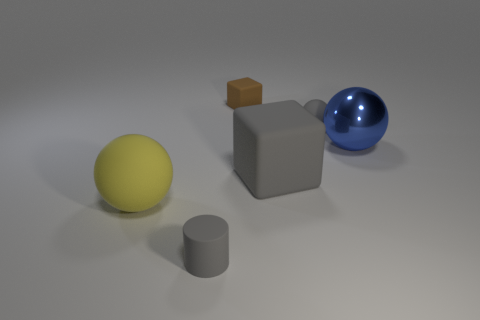Subtract 1 spheres. How many spheres are left? 2 Add 3 small balls. How many objects exist? 9 Subtract all cylinders. How many objects are left? 5 Subtract all balls. Subtract all tiny brown cubes. How many objects are left? 2 Add 6 gray matte spheres. How many gray matte spheres are left? 7 Add 4 gray matte balls. How many gray matte balls exist? 5 Subtract 0 brown balls. How many objects are left? 6 